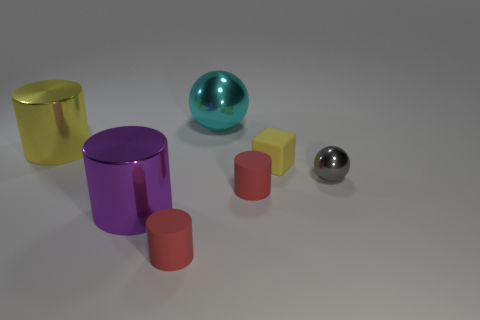What material is the yellow block that is the same size as the gray metal thing?
Your answer should be compact. Rubber. How many other things are made of the same material as the small yellow block?
Provide a short and direct response. 2. How many yellow things are left of the small matte block?
Give a very brief answer. 1. How many spheres are either big yellow objects or yellow matte things?
Make the answer very short. 0. What size is the metallic thing that is right of the purple metal cylinder and to the left of the tiny metallic sphere?
Your response must be concise. Large. How many other things are there of the same color as the large metal sphere?
Your response must be concise. 0. Is the large cyan object made of the same material as the large object that is in front of the gray metal object?
Provide a succinct answer. Yes. What number of objects are small things in front of the tiny yellow rubber block or yellow shiny cylinders?
Keep it short and to the point. 4. There is a rubber object that is to the right of the cyan ball and to the left of the yellow rubber object; what is its shape?
Keep it short and to the point. Cylinder. There is a gray ball that is the same material as the big purple cylinder; what size is it?
Give a very brief answer. Small. 